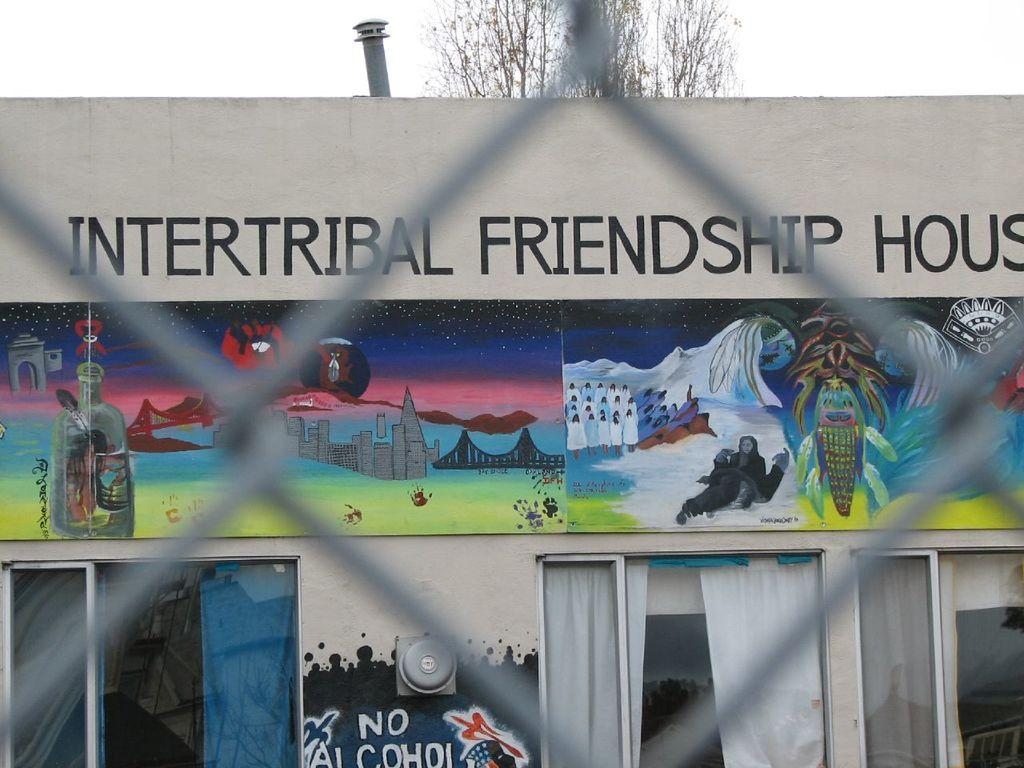What type of structure is visible in the image? There is a building in the image. What can be seen on the wall of the building? There is text and pictures on the wall in the image. What type of window treatment is present in the image? There are curtains on the windows in the image. What natural element is visible in the image? There is a tree visible in the image. How would you describe the weather based on the image? The sky is cloudy in the image, suggesting a potentially overcast or cloudy day. What type of leather is visible on the chin of the person in the image? There is no person present in the image, and therefore no leather or chin can be observed. 